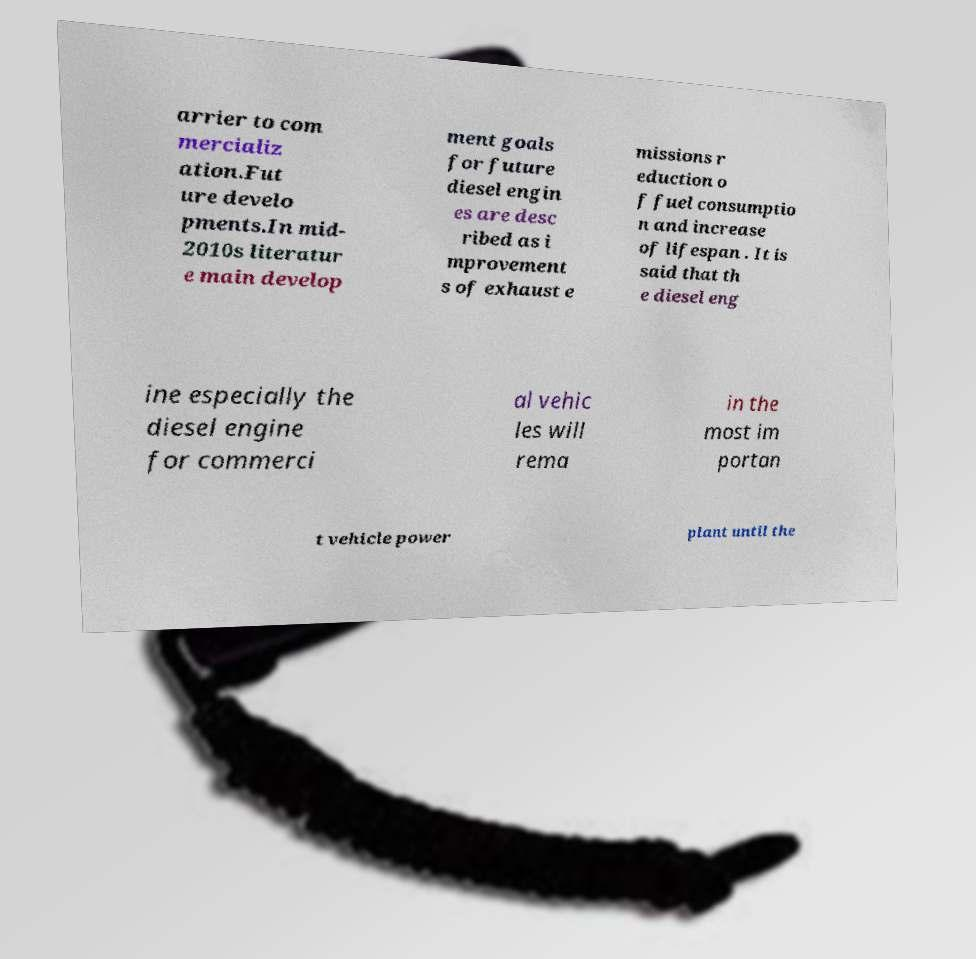Can you accurately transcribe the text from the provided image for me? arrier to com mercializ ation.Fut ure develo pments.In mid- 2010s literatur e main develop ment goals for future diesel engin es are desc ribed as i mprovement s of exhaust e missions r eduction o f fuel consumptio n and increase of lifespan . It is said that th e diesel eng ine especially the diesel engine for commerci al vehic les will rema in the most im portan t vehicle power plant until the 